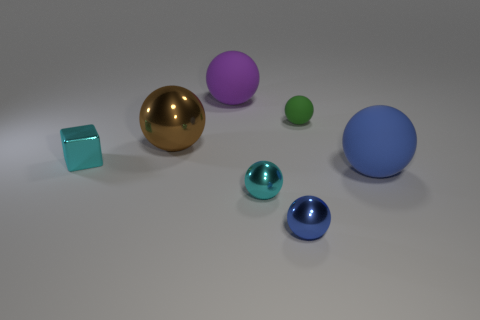Is there a big brown object that has the same material as the purple object?
Your response must be concise. No. Are there more big spheres than small cyan metal spheres?
Your answer should be compact. Yes. Is the block made of the same material as the big brown object?
Your answer should be compact. Yes. What number of matte objects are either balls or small cyan blocks?
Your answer should be compact. 3. What color is the block that is the same size as the blue shiny object?
Ensure brevity in your answer.  Cyan. How many blue matte things are the same shape as the purple object?
Your answer should be compact. 1. What number of spheres are either cyan metallic things or tiny green things?
Make the answer very short. 2. Is the shape of the matte object that is left of the small blue object the same as the big thing right of the small blue metallic sphere?
Your answer should be compact. Yes. What material is the tiny cyan cube?
Offer a terse response. Metal. The tiny thing that is the same color as the metallic block is what shape?
Give a very brief answer. Sphere. 